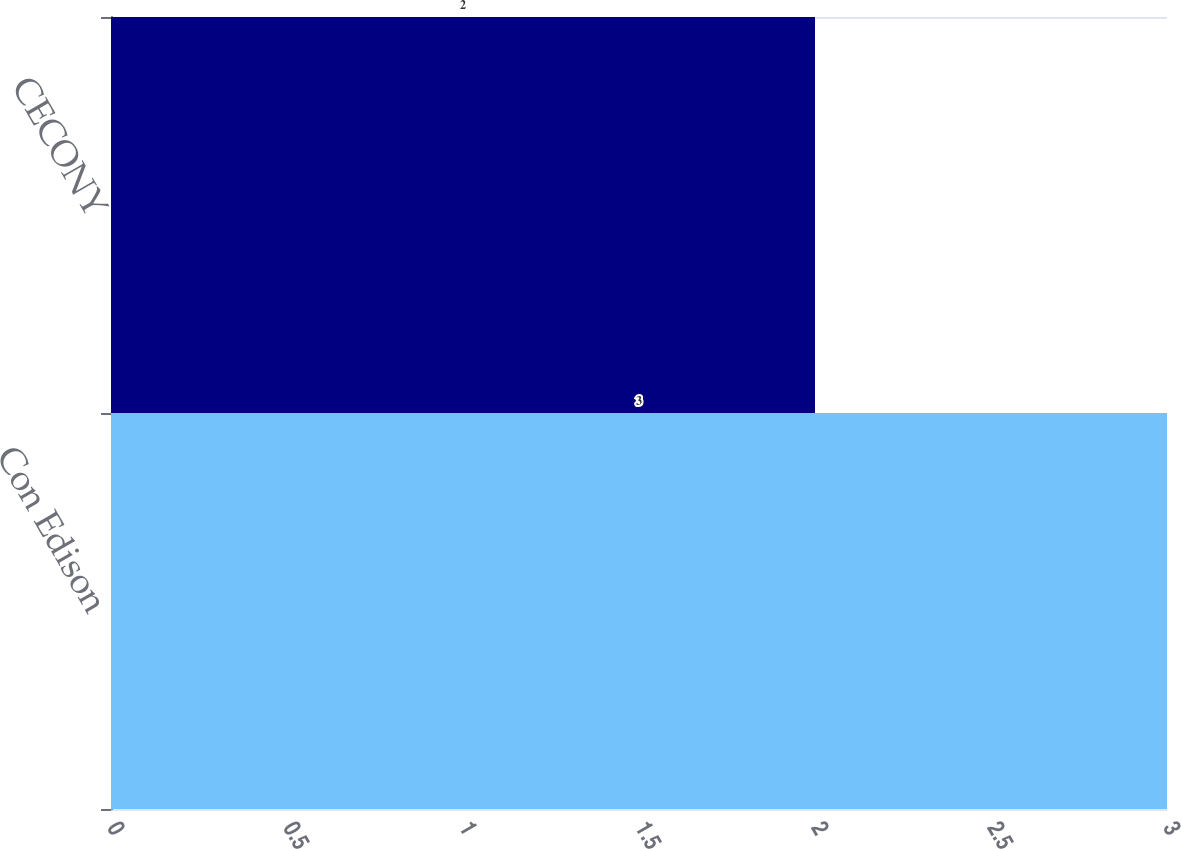Convert chart. <chart><loc_0><loc_0><loc_500><loc_500><bar_chart><fcel>Con Edison<fcel>CECONY<nl><fcel>3<fcel>2<nl></chart> 